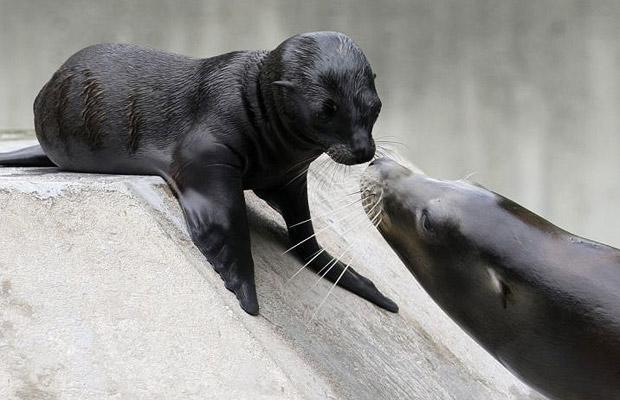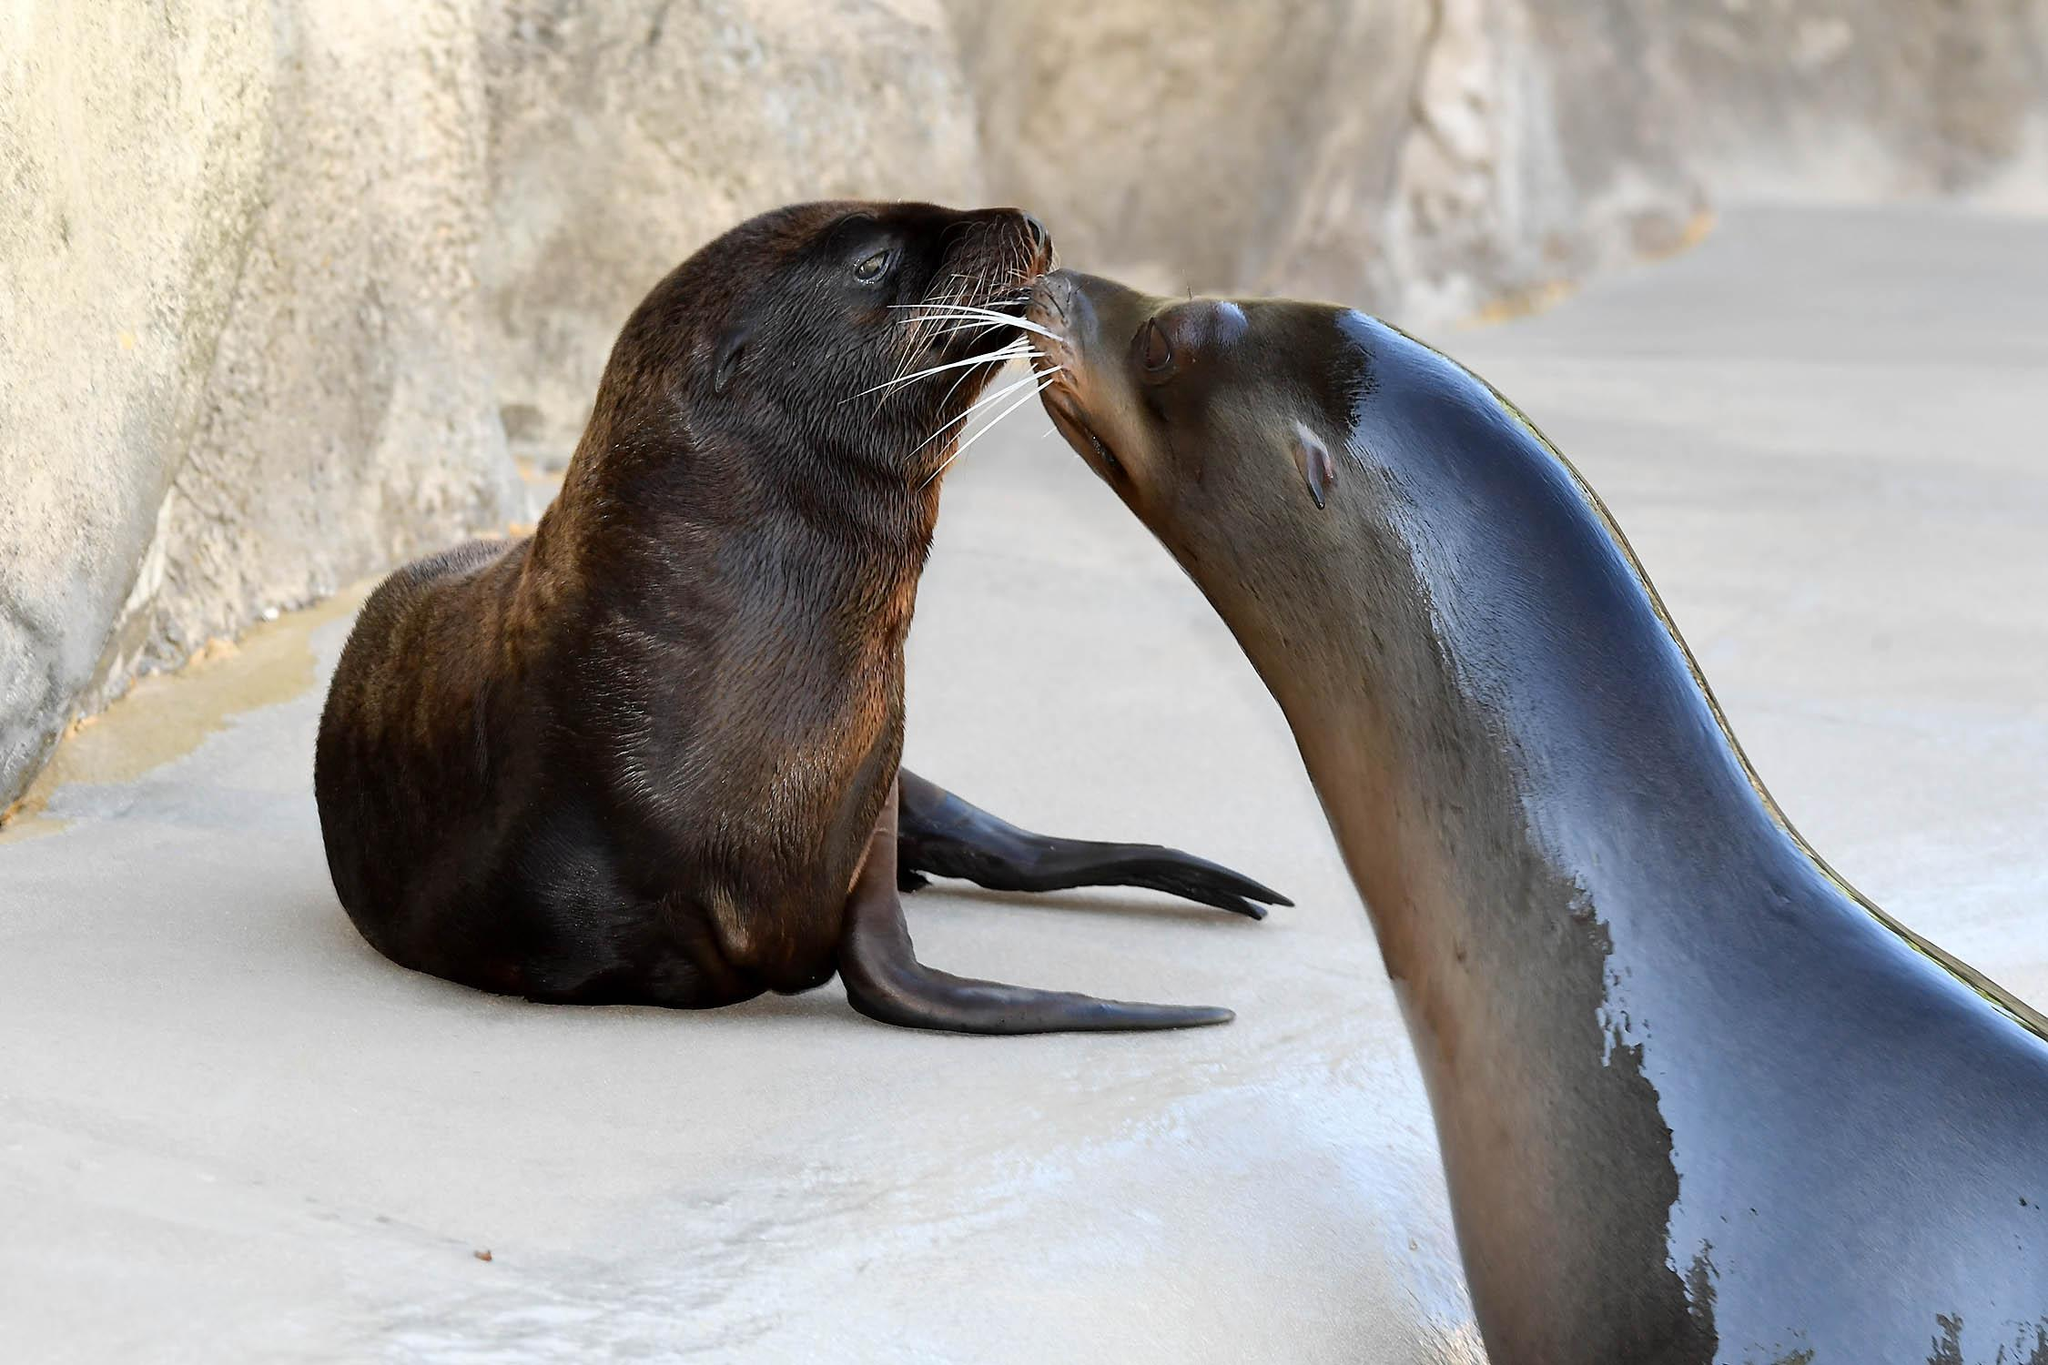The first image is the image on the left, the second image is the image on the right. Analyze the images presented: Is the assertion "There are exactly three sea lions in total." valid? Answer yes or no. No. The first image is the image on the left, the second image is the image on the right. Examine the images to the left and right. Is the description "One image contains a single seal with head and shoulders upright, and the other image contains exactly two seals in the same scene together." accurate? Answer yes or no. No. 